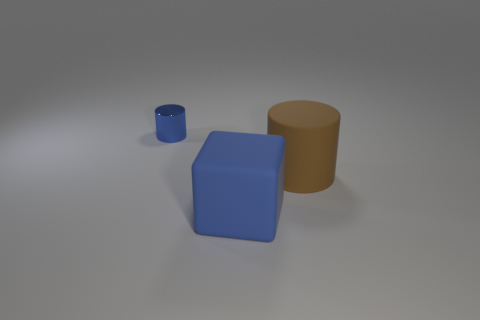What kind of lighting is being used in this scene? The scene is softly lit with what seems to be a diffuse, omnidirectional light source, casting gentle shadows onto the grey surface. This gives the objects a three-dimensional quality and highlights their matte surfaces. 